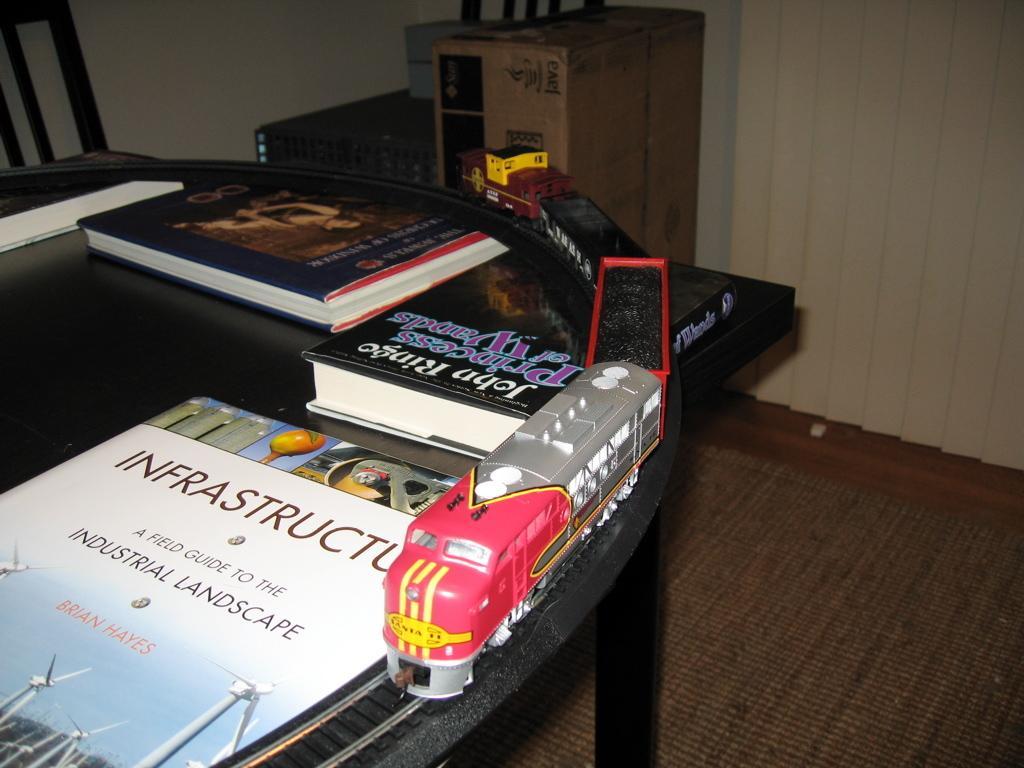Can you describe this image briefly? This picture is clicked inside. On the left we can see a toy of a train running on the railway track which is placed on the top of the table and we can see there are some books placed on the top of the table. In the background we can see the wall, chair and some objects placed on the ground. 